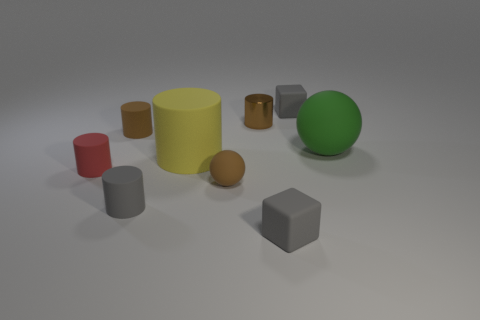There is a brown rubber thing in front of the large green ball; is its shape the same as the big green thing?
Make the answer very short. Yes. What number of things are large green objects that are on the right side of the red matte thing or matte things in front of the yellow rubber cylinder?
Ensure brevity in your answer.  5. What is the color of the big rubber thing that is the same shape as the tiny red object?
Ensure brevity in your answer.  Yellow. Is there any other thing that has the same shape as the red rubber thing?
Ensure brevity in your answer.  Yes. There is a brown metal object; does it have the same shape as the gray rubber thing left of the yellow cylinder?
Provide a succinct answer. Yes. What is the material of the red cylinder?
Keep it short and to the point. Rubber. There is a yellow thing that is the same shape as the small red thing; what size is it?
Provide a succinct answer. Large. How many other objects are the same material as the red thing?
Offer a terse response. 7. Is the brown sphere made of the same material as the gray block that is in front of the large matte ball?
Your response must be concise. Yes. Are there fewer gray matte things right of the large green sphere than shiny cylinders behind the brown metallic object?
Your answer should be compact. No. 